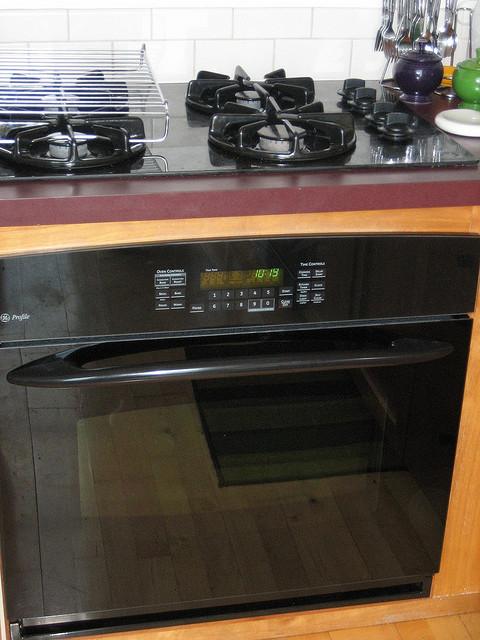What color is the oven?
Quick response, please. Black. What is the brand of oven in the picture?
Short answer required. Ge. What is the flooring?
Quick response, please. Wood. 